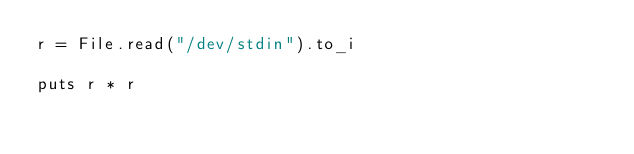Convert code to text. <code><loc_0><loc_0><loc_500><loc_500><_Crystal_>r = File.read("/dev/stdin").to_i

puts r * r
</code> 